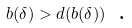<formula> <loc_0><loc_0><loc_500><loc_500>b ( \delta ) > d ( b ( \delta ) ) \text { .}</formula> 